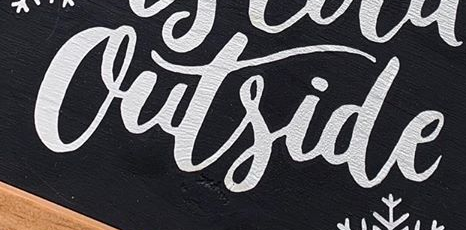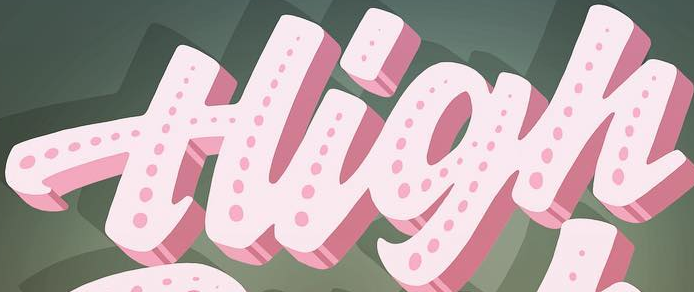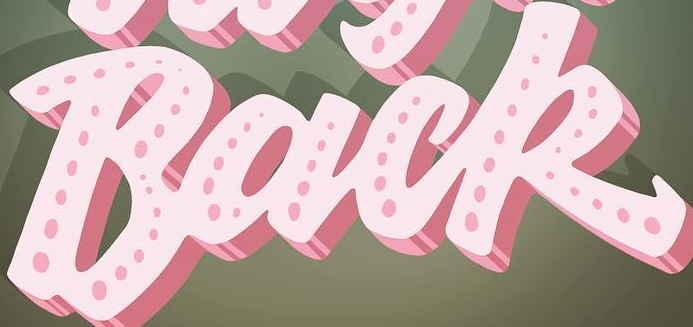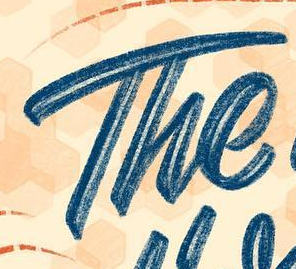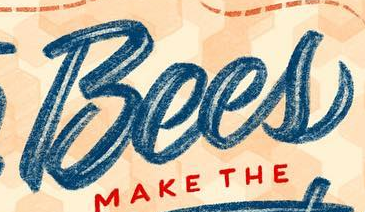What words can you see in these images in sequence, separated by a semicolon? Outside; High; Back; The; Bees 